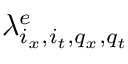<formula> <loc_0><loc_0><loc_500><loc_500>\lambda _ { i _ { x } , i _ { t } , q _ { x } , q _ { t } } ^ { e }</formula> 